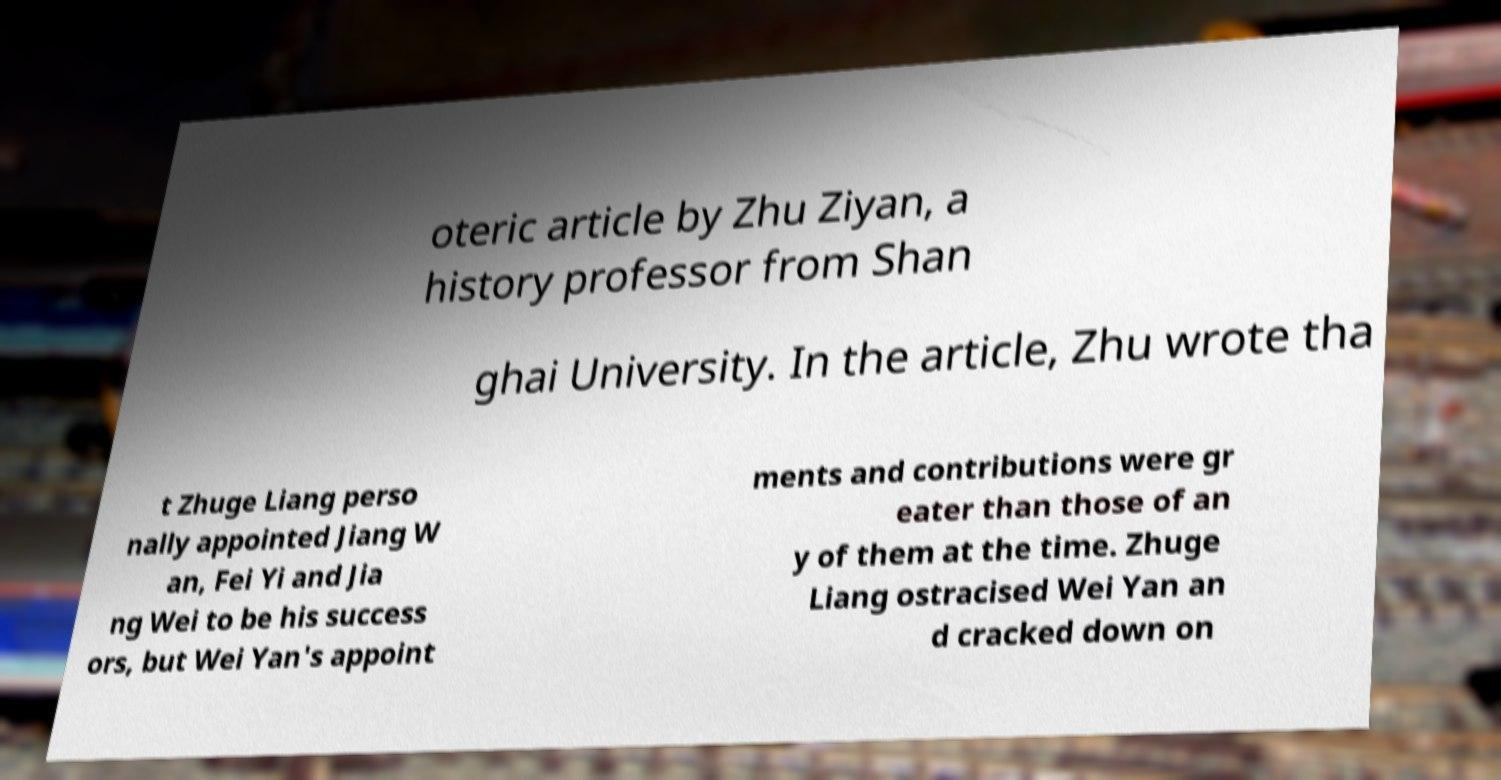I need the written content from this picture converted into text. Can you do that? oteric article by Zhu Ziyan, a history professor from Shan ghai University. In the article, Zhu wrote tha t Zhuge Liang perso nally appointed Jiang W an, Fei Yi and Jia ng Wei to be his success ors, but Wei Yan's appoint ments and contributions were gr eater than those of an y of them at the time. Zhuge Liang ostracised Wei Yan an d cracked down on 